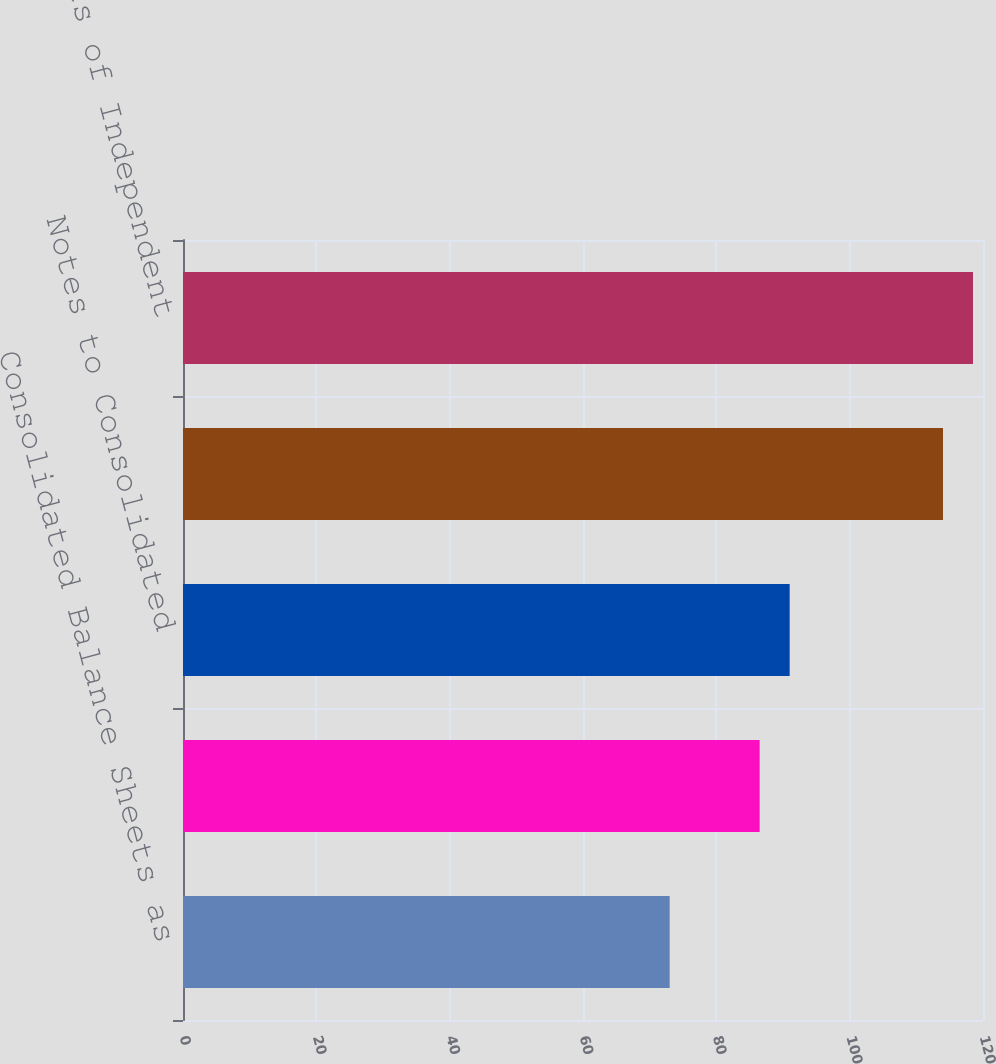Convert chart to OTSL. <chart><loc_0><loc_0><loc_500><loc_500><bar_chart><fcel>Consolidated Balance Sheets as<fcel>Consolidated Statements of<fcel>Notes to Consolidated<fcel>Selected Quarterly Financial<fcel>Reports of Independent<nl><fcel>73<fcel>86.5<fcel>91<fcel>114<fcel>118.5<nl></chart> 